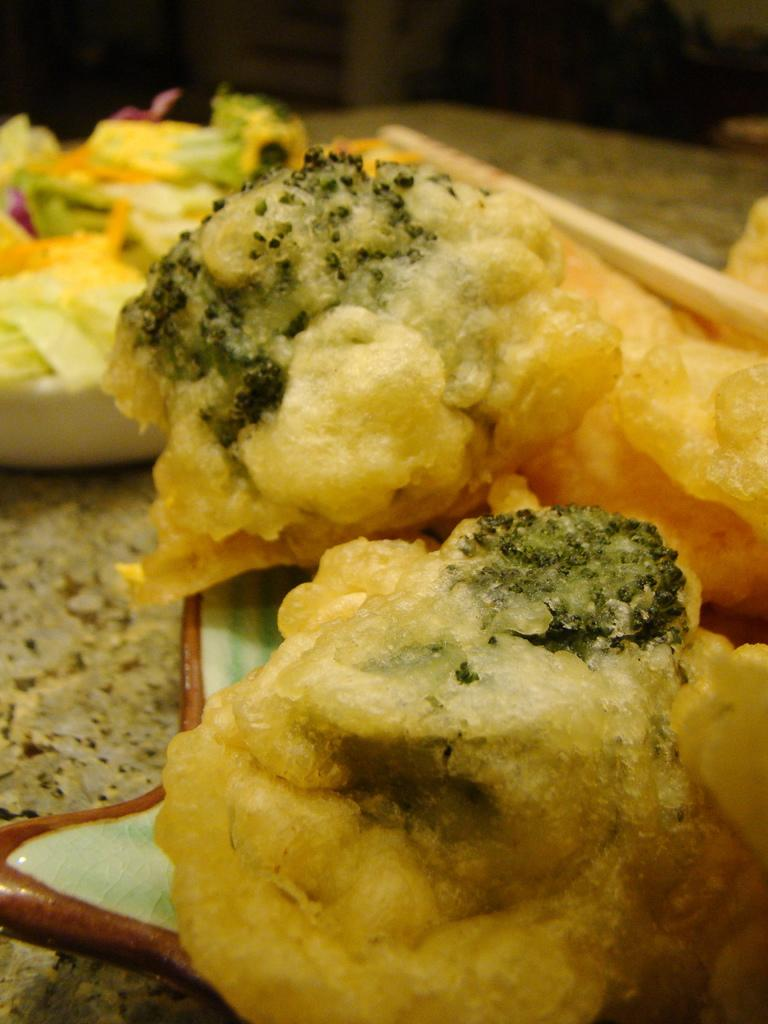What is present on the plate in the image? There is food on the plate in the image. Can you describe the other food item visible in the image? There is another food item beside the plate in the image. How many worms can be seen crawling on the plate in the image? There are no worms present on the plate or in the image. 